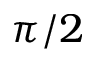<formula> <loc_0><loc_0><loc_500><loc_500>\pi / 2</formula> 